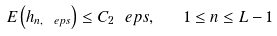Convert formula to latex. <formula><loc_0><loc_0><loc_500><loc_500>E \left ( h _ { n , \ e p s } \right ) \leq C _ { 2 } \ e p s , \quad 1 \leq n \leq L - 1</formula> 